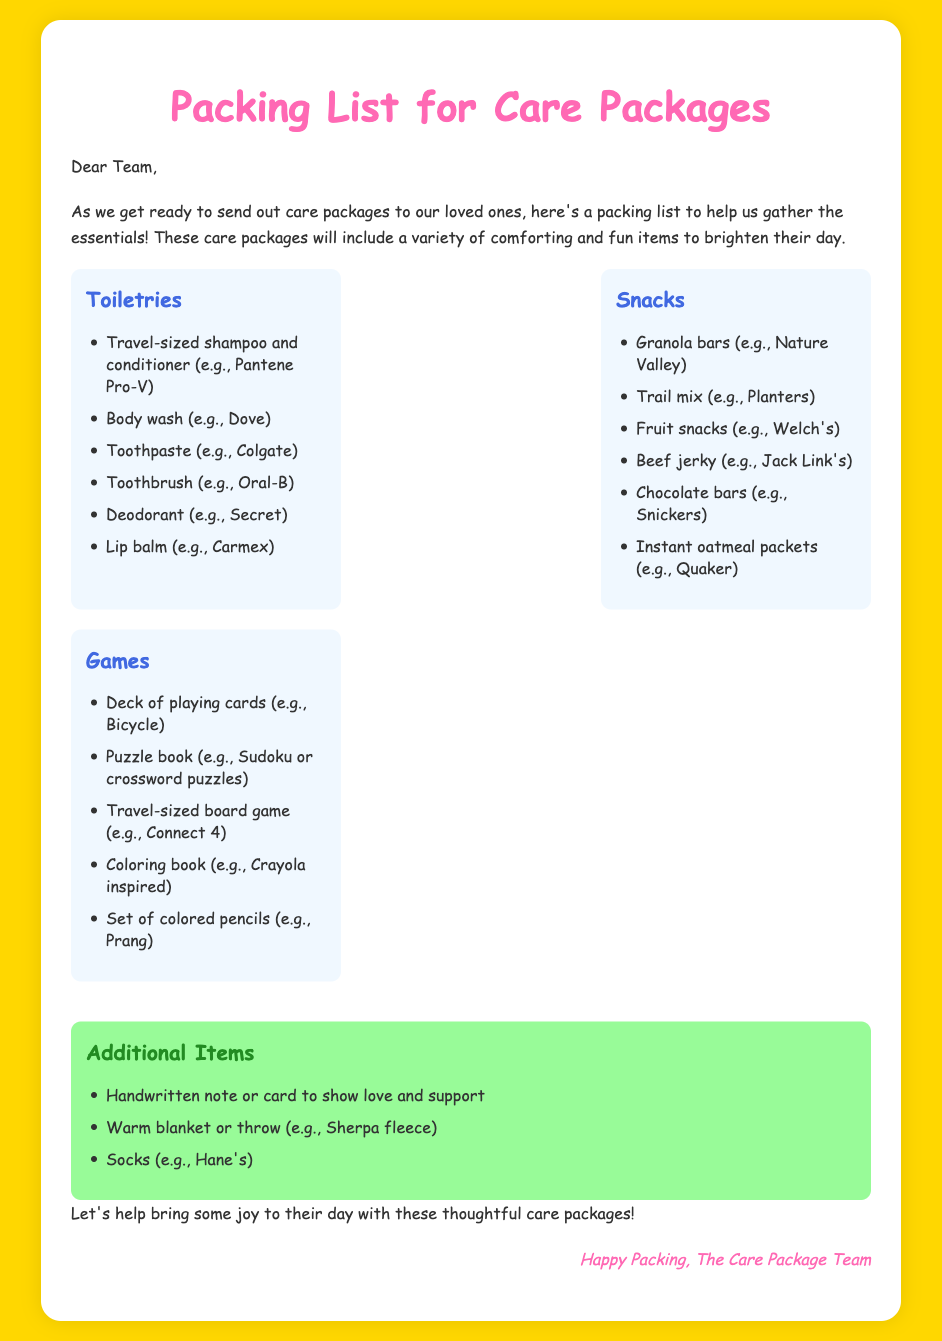What are the three main categories of items in the care package? The categories listed are Toiletries, Snacks, and Games.
Answer: Toiletries, Snacks, and Games How many toiletries are listed in the packing list? There are six items listed under the Toiletries category.
Answer: 6 Which brand of toothpaste is mentioned? The document specifies Colgate as the brand of toothpaste.
Answer: Colgate What additional item is suggested to include a handwritten note or card? The additional items include a handwritten note or card to show love and support.
Answer: Handwritten note or card What type of game is suggested for the care package? A deck of playing cards is among the games suggested in the document.
Answer: Deck of playing cards What color is the background of the memo? The background color of the memo is golden yellow.
Answer: Golden yellow How is the memo signed off? The memo is signed off as "Happy Packing, The Care Package Team."
Answer: Happy Packing, The Care Package Team What is the purpose of this packing list? The purpose is to help gather essentials for sending care packages.
Answer: To help gather essentials for sending care packages 